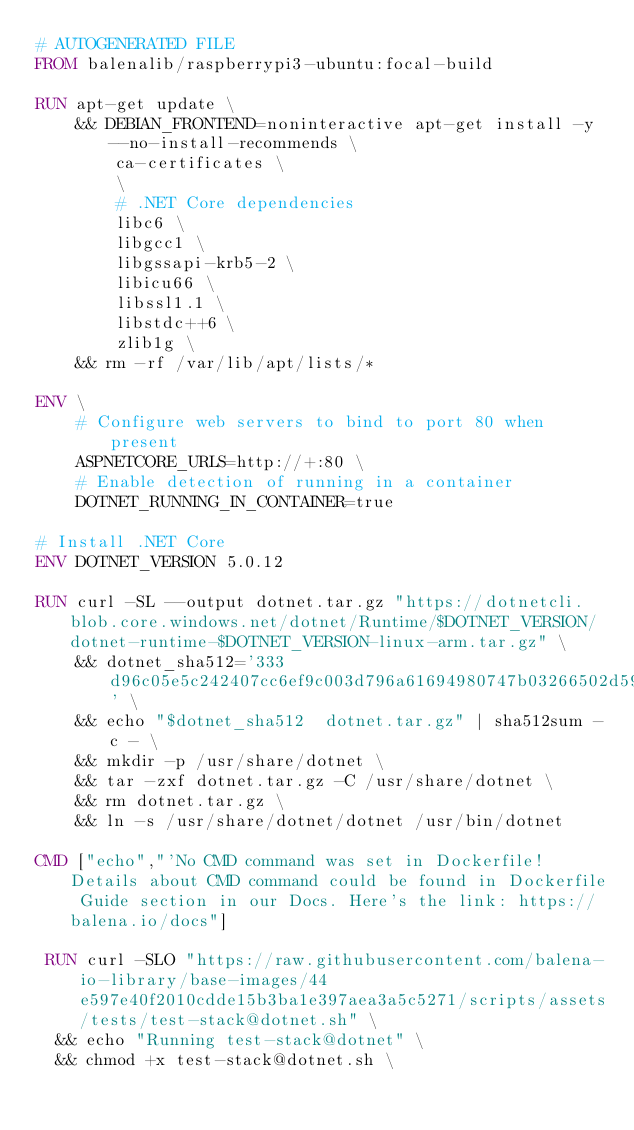Convert code to text. <code><loc_0><loc_0><loc_500><loc_500><_Dockerfile_># AUTOGENERATED FILE
FROM balenalib/raspberrypi3-ubuntu:focal-build

RUN apt-get update \
    && DEBIAN_FRONTEND=noninteractive apt-get install -y --no-install-recommends \
        ca-certificates \
        \
        # .NET Core dependencies
        libc6 \
        libgcc1 \
        libgssapi-krb5-2 \
        libicu66 \
        libssl1.1 \
        libstdc++6 \
        zlib1g \
    && rm -rf /var/lib/apt/lists/*

ENV \
    # Configure web servers to bind to port 80 when present
    ASPNETCORE_URLS=http://+:80 \
    # Enable detection of running in a container
    DOTNET_RUNNING_IN_CONTAINER=true

# Install .NET Core
ENV DOTNET_VERSION 5.0.12

RUN curl -SL --output dotnet.tar.gz "https://dotnetcli.blob.core.windows.net/dotnet/Runtime/$DOTNET_VERSION/dotnet-runtime-$DOTNET_VERSION-linux-arm.tar.gz" \
    && dotnet_sha512='333d96c05e5c242407cc6ef9c003d796a61694980747b03266502d593d3e1c66d5e6147bfb41796df76ff0144617ee33c56afba740dd3eb4ea090a742b1c73d4' \
    && echo "$dotnet_sha512  dotnet.tar.gz" | sha512sum -c - \
    && mkdir -p /usr/share/dotnet \
    && tar -zxf dotnet.tar.gz -C /usr/share/dotnet \
    && rm dotnet.tar.gz \
    && ln -s /usr/share/dotnet/dotnet /usr/bin/dotnet

CMD ["echo","'No CMD command was set in Dockerfile! Details about CMD command could be found in Dockerfile Guide section in our Docs. Here's the link: https://balena.io/docs"]

 RUN curl -SLO "https://raw.githubusercontent.com/balena-io-library/base-images/44e597e40f2010cdde15b3ba1e397aea3a5c5271/scripts/assets/tests/test-stack@dotnet.sh" \
  && echo "Running test-stack@dotnet" \
  && chmod +x test-stack@dotnet.sh \</code> 